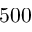<formula> <loc_0><loc_0><loc_500><loc_500>5 0 0</formula> 